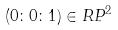Convert formula to latex. <formula><loc_0><loc_0><loc_500><loc_500>( 0 \colon 0 \colon 1 ) \in R P ^ { 2 }</formula> 